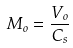Convert formula to latex. <formula><loc_0><loc_0><loc_500><loc_500>M _ { o } = \frac { V _ { o } } { C _ { s } }</formula> 